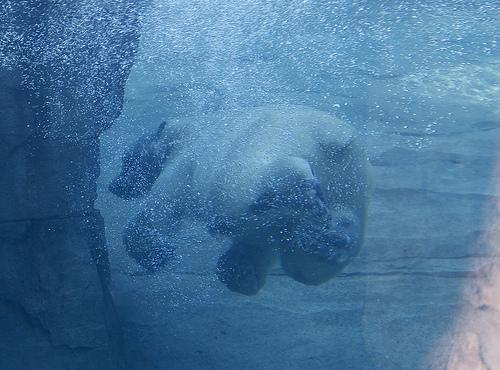Question: what is the animal?
Choices:
A. Cat.
B. Goat.
C. Bear.
D. Lion.
Answer with the letter. Answer: C Question: who feeds the bear?
Choices:
A. Mailman.
B. Teacher.
C. Zookeeper.
D. Engineer.
Answer with the letter. Answer: C Question: why is the bear in the water?
Choices:
A. Eat.
B. Swim.
C. Sleep.
D. Play.
Answer with the letter. Answer: B 